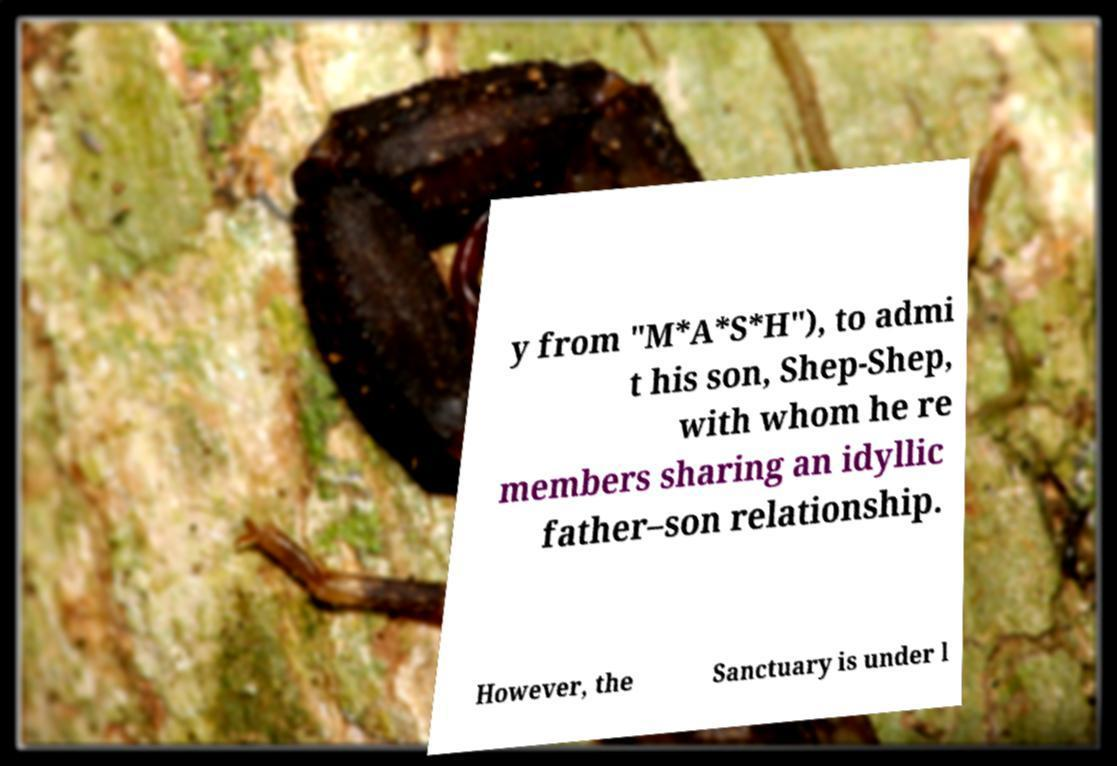Please read and relay the text visible in this image. What does it say? y from "M*A*S*H"), to admi t his son, Shep-Shep, with whom he re members sharing an idyllic father–son relationship. However, the Sanctuary is under l 